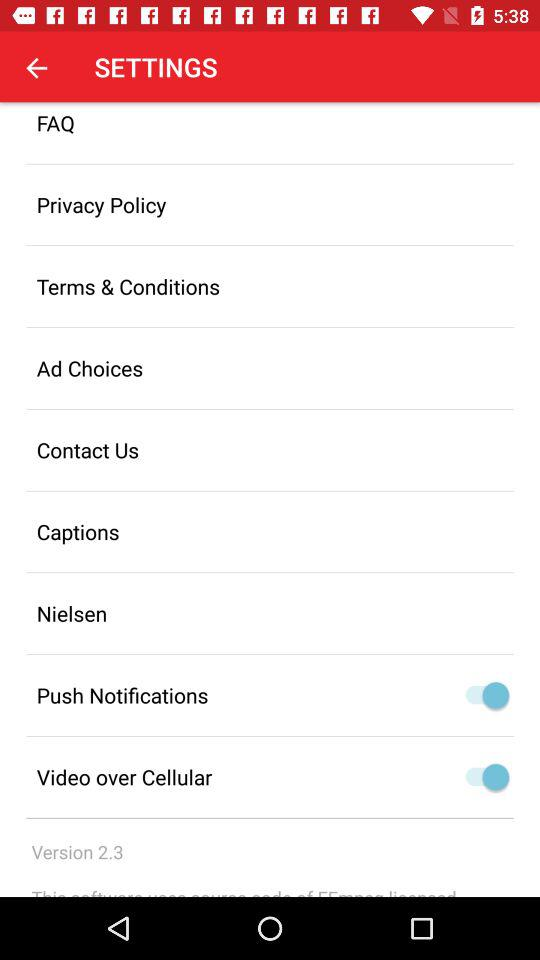What is the version? The version is 2.3. 